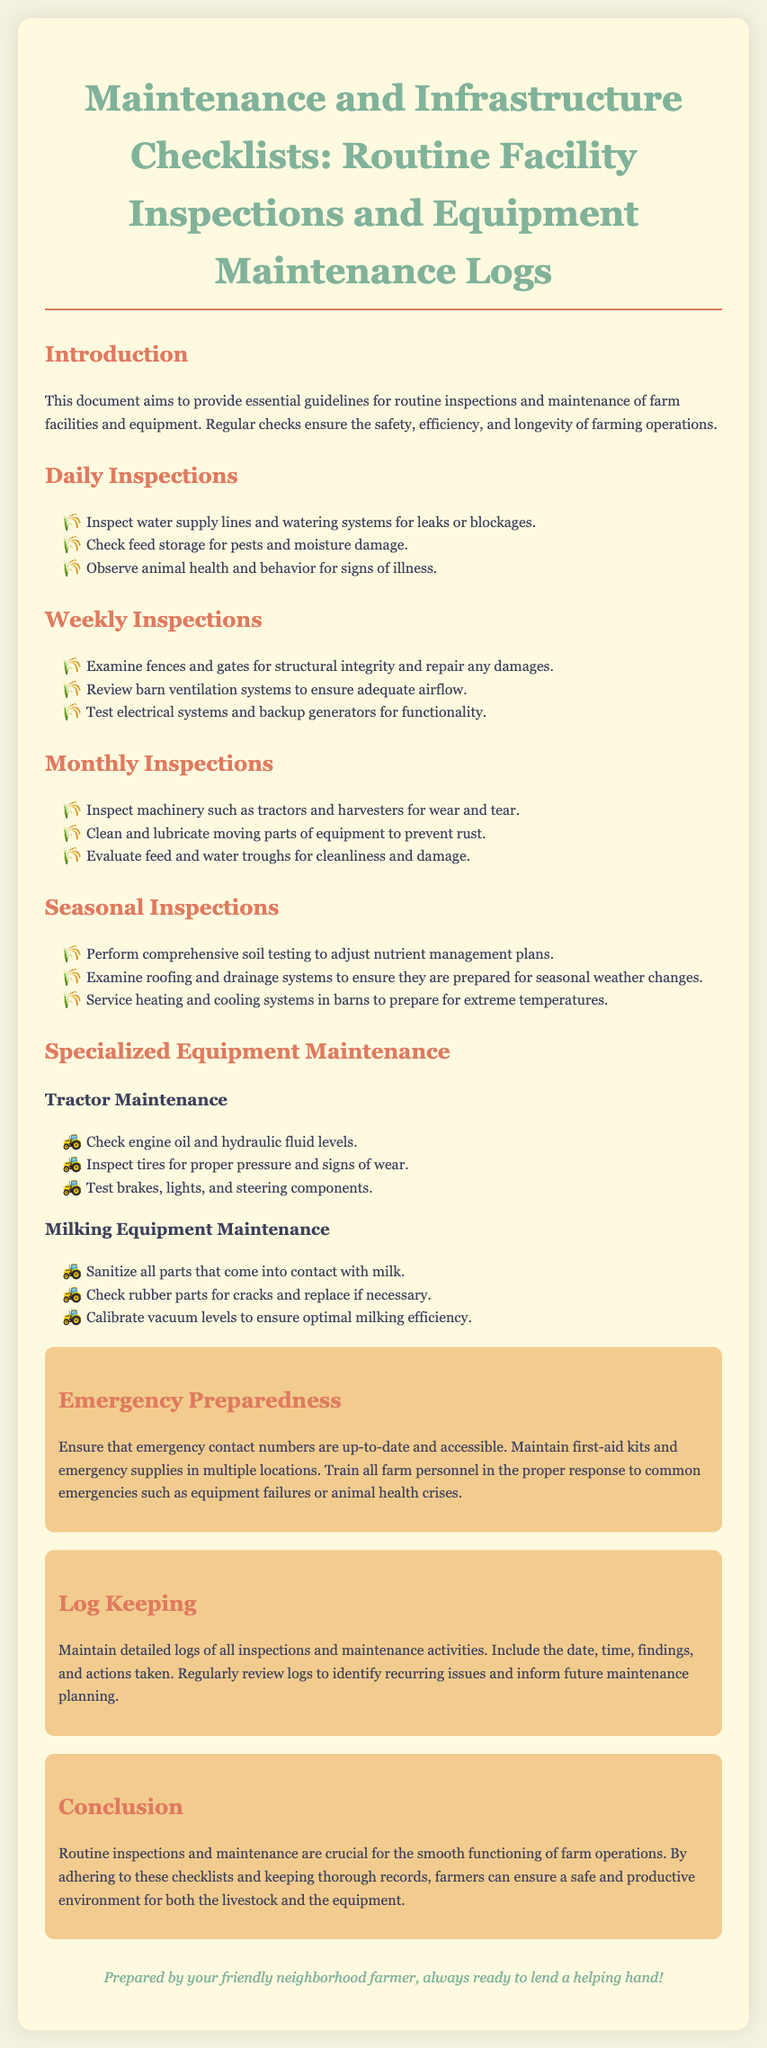What is the title of the document? The title of the document is stated at the top of the rendered document.
Answer: Maintenance and Infrastructure Checklists: Routine Facility Inspections and Equipment Maintenance Logs What is one item inspected daily? The document lists specific items to be inspected daily.
Answer: Inspect water supply lines How often are barns' ventilation systems checked? The document indicates how often different inspections occur for structured maintenance.
Answer: Weekly What is a seasonal inspection task? The document details tasks to be completed for seasonal inspections.
Answer: Perform comprehensive soil testing What should be sanitized in milking equipment? The document specifies items that require sanitization during maintenance of milking equipment.
Answer: All parts that come into contact with milk What should be recorded in maintenance logs? The document emphasizes the importance of maintaining logs and what they should include.
Answer: Date, time, findings, and actions taken Which part of the document discusses emergency procedures? The structure of the document provides specific sections that cover various topics, including emergencies.
Answer: Emergency Preparedness How many types of inspections are listed? The document outlines various frequency categories for inspections.
Answer: Four What is the purpose of routine inspections? The document provides insights into the overarching aim of conducting routine inspections.
Answer: Ensure the safety, efficiency, and longevity of farming operations 